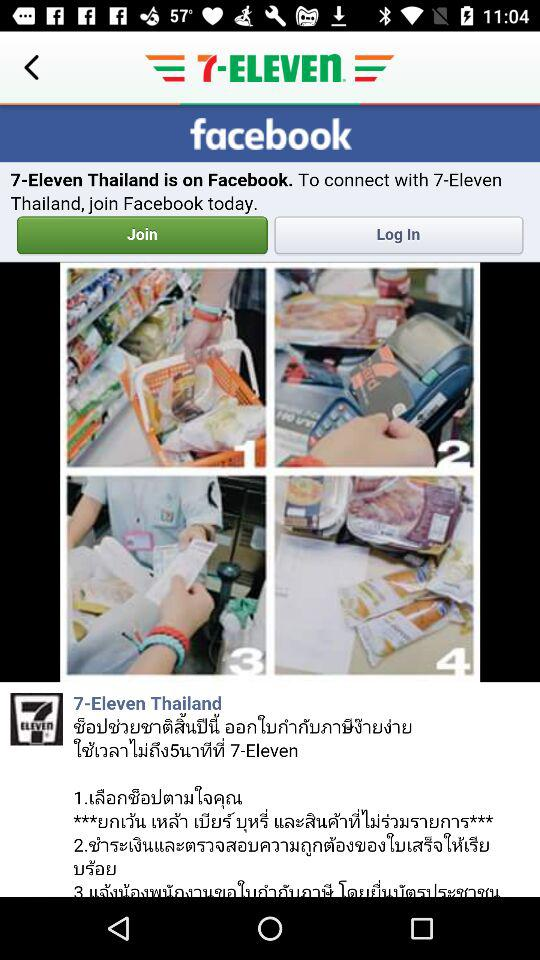What is the application name? The application name is "facebook". 